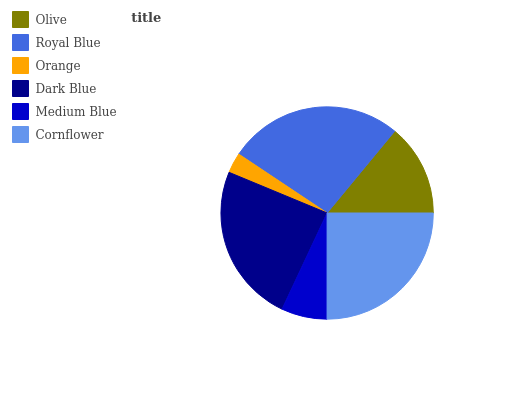Is Orange the minimum?
Answer yes or no. Yes. Is Royal Blue the maximum?
Answer yes or no. Yes. Is Royal Blue the minimum?
Answer yes or no. No. Is Orange the maximum?
Answer yes or no. No. Is Royal Blue greater than Orange?
Answer yes or no. Yes. Is Orange less than Royal Blue?
Answer yes or no. Yes. Is Orange greater than Royal Blue?
Answer yes or no. No. Is Royal Blue less than Orange?
Answer yes or no. No. Is Dark Blue the high median?
Answer yes or no. Yes. Is Olive the low median?
Answer yes or no. Yes. Is Olive the high median?
Answer yes or no. No. Is Royal Blue the low median?
Answer yes or no. No. 